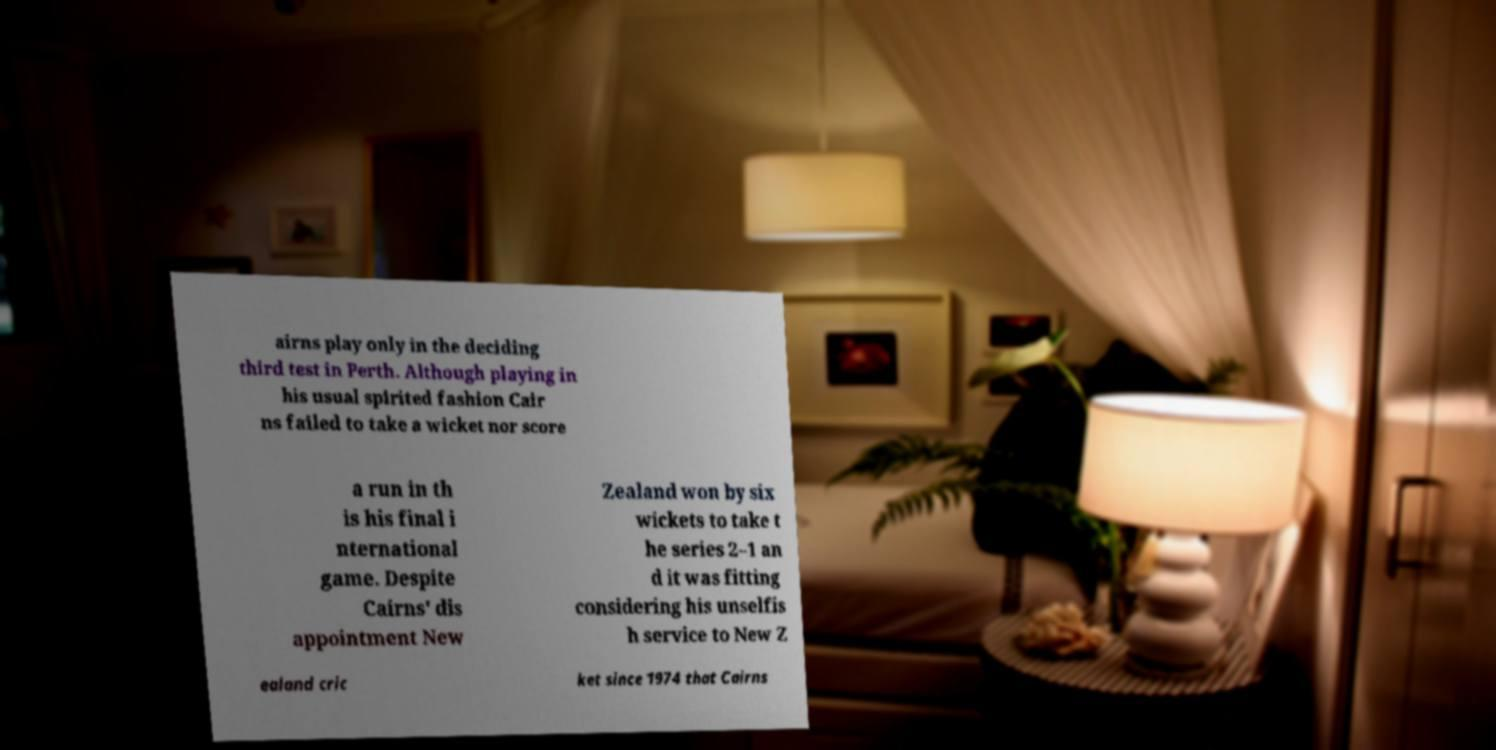Please identify and transcribe the text found in this image. airns play only in the deciding third test in Perth. Although playing in his usual spirited fashion Cair ns failed to take a wicket nor score a run in th is his final i nternational game. Despite Cairns' dis appointment New Zealand won by six wickets to take t he series 2–1 an d it was fitting considering his unselfis h service to New Z ealand cric ket since 1974 that Cairns 